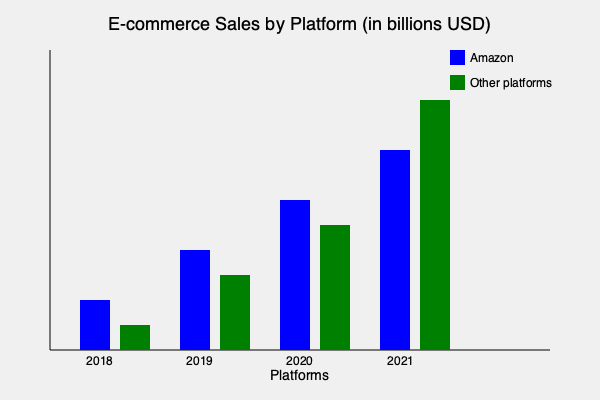Analyzing the bar chart of e-commerce sales evolution from 2018 to 2021, what significant trend can be observed in the market dynamics between Amazon and other platforms, and how might this trend impact future market disruptions in the e-commerce sector? To answer this question, we need to analyze the trends shown in the bar chart:

1. Amazon's growth:
   - 2018: ~$50 billion
   - 2019: ~$100 billion
   - 2020: ~$150 billion
   - 2021: ~$200 billion
   Amazon shows steady, linear growth year over year.

2. Other platforms' growth:
   - 2018: ~$25 billion
   - 2019: ~$75 billion
   - 2020: ~$125 billion
   - 2021: ~$250 billion
   Other platforms show exponential growth, especially from 2020 to 2021.

3. Comparative analysis:
   - 2018-2020: Amazon maintained a lead over other platforms.
   - 2021: Other platforms surpassed Amazon in total sales.

4. Market dynamics:
   - The e-commerce market is expanding rapidly for all players.
   - Other platforms are gaining market share at a faster rate than Amazon.
   - This suggests increasing competition and potential market disruption.

5. Future implications:
   - The trend indicates a shift towards a more diverse e-commerce ecosystem.
   - Emerging technologies and platforms are challenging established leaders.
   - This could lead to increased innovation and consumer choice in the sector.

The significant trend is the accelerating growth of other platforms, overtaking Amazon in 2021, which suggests a potential disruption in the e-commerce market leadership and structure.
Answer: Accelerating growth of alternative platforms, surpassing Amazon in 2021, indicating potential market disruption and increased competition in e-commerce. 